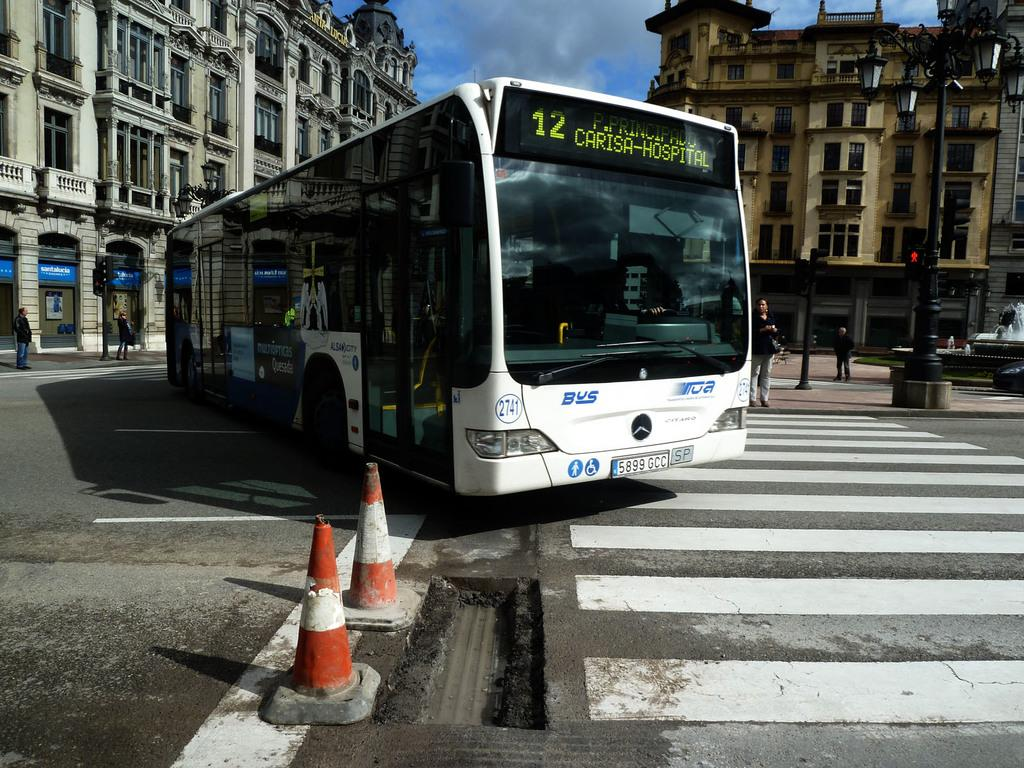<image>
Summarize the visual content of the image. White bus going to Carisa Hospital making a turn. 